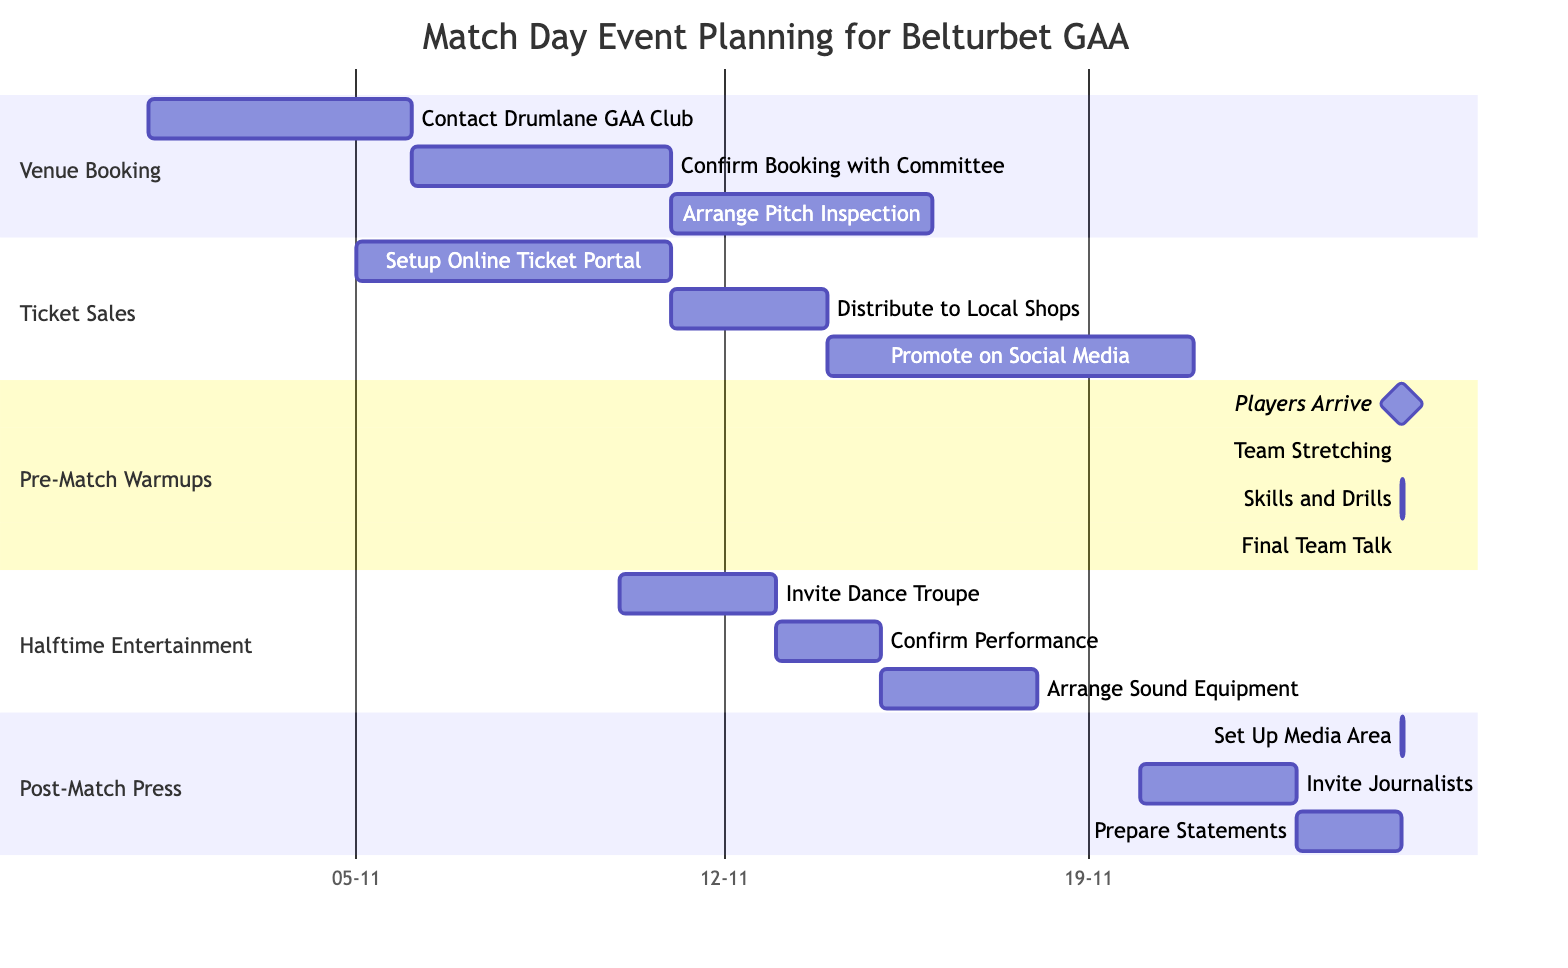What is the duration for Venue Booking? The tasks under Venue Booking have the start and end dates as follows: "Contact Drumlane GAA Club" from November 1 to November 5, "Confirm Booking with Belturbet GAA Committee" from November 6 to November 10, and "Arrange Pitch Inspection" from November 11 to November 15. The total duration considering the tasks is 15 days (5+5+5).
Answer: 15 days Which task starts on November 14? Among the tasks listed, only "Promote Ticket Sales on Social Media" starts on November 14 and runs until November 20. The other tasks either end before or start after this date.
Answer: Promote Ticket Sales on Social Media How many tasks are scheduled for Pre-Match Warmups? There are four distinct tasks scheduled under Pre-Match Warmups. They include "Players Arrive at Venue," "Team Stretching Exercises," "Skills and Drills Session," and "Final Team Talk." This information can be directly counted from the section.
Answer: 4 tasks What is the latest date for confirming the Halftime Entertainment schedule? "Confirm Performance Schedule" is the task in the Halftime Entertainment section that ends on November 14. This reflects the latest date for confirming entertainment arrangements before the match.
Answer: November 14 What is the start time for Players Arrive at Venue? The task "Players Arrive at Venue" explicitly states it starts on November 25 at 10:00 AM. This can be found under the Pre-Match Warmups tasks.
Answer: 10:00 AM What is the relationship between Ticket Sales and Halftime Entertainment? The Ticket Sales section has tasks that finish before the Halftime Entertainment tasks start, which indicates that the operations for selling tickets are completed prior to the entertainment arrangements being finalized. This sequential relationship is clear from the timing of the tasks.
Answer: Sequential Which task follows "Invite Journalists and Reporters"? The task that follows "Invite Journalists and Reporters" is "Prepare Statements and Q&A Session," which starts on November 23 after the invitation period ends on November 22. This sequential order is evident within the Planning section.
Answer: Prepare Statements and Q&A Session What is the total time allocated for the Players Arrive at Venue task? The task "Players Arrive" is listed as a milestone for 30 minutes on the day of the match, which means it has a very short allocated time. This is detailed within the times assigned to tasks in the Pre-Match Warmups section.
Answer: 30 minutes 